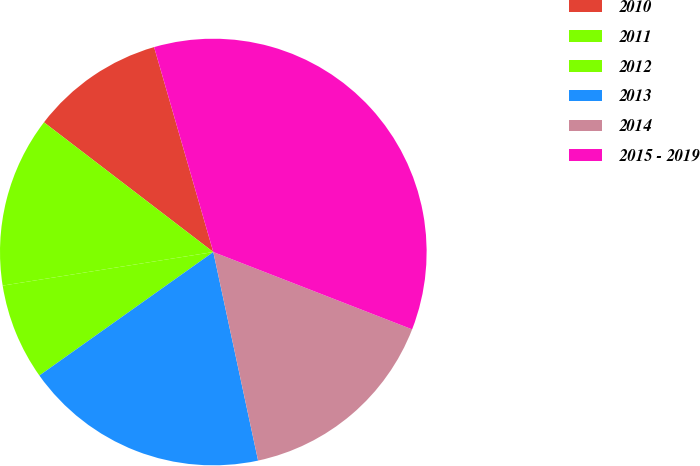Convert chart to OTSL. <chart><loc_0><loc_0><loc_500><loc_500><pie_chart><fcel>2010<fcel>2011<fcel>2012<fcel>2013<fcel>2014<fcel>2015 - 2019<nl><fcel>10.12%<fcel>12.92%<fcel>7.31%<fcel>18.54%<fcel>15.73%<fcel>35.38%<nl></chart> 